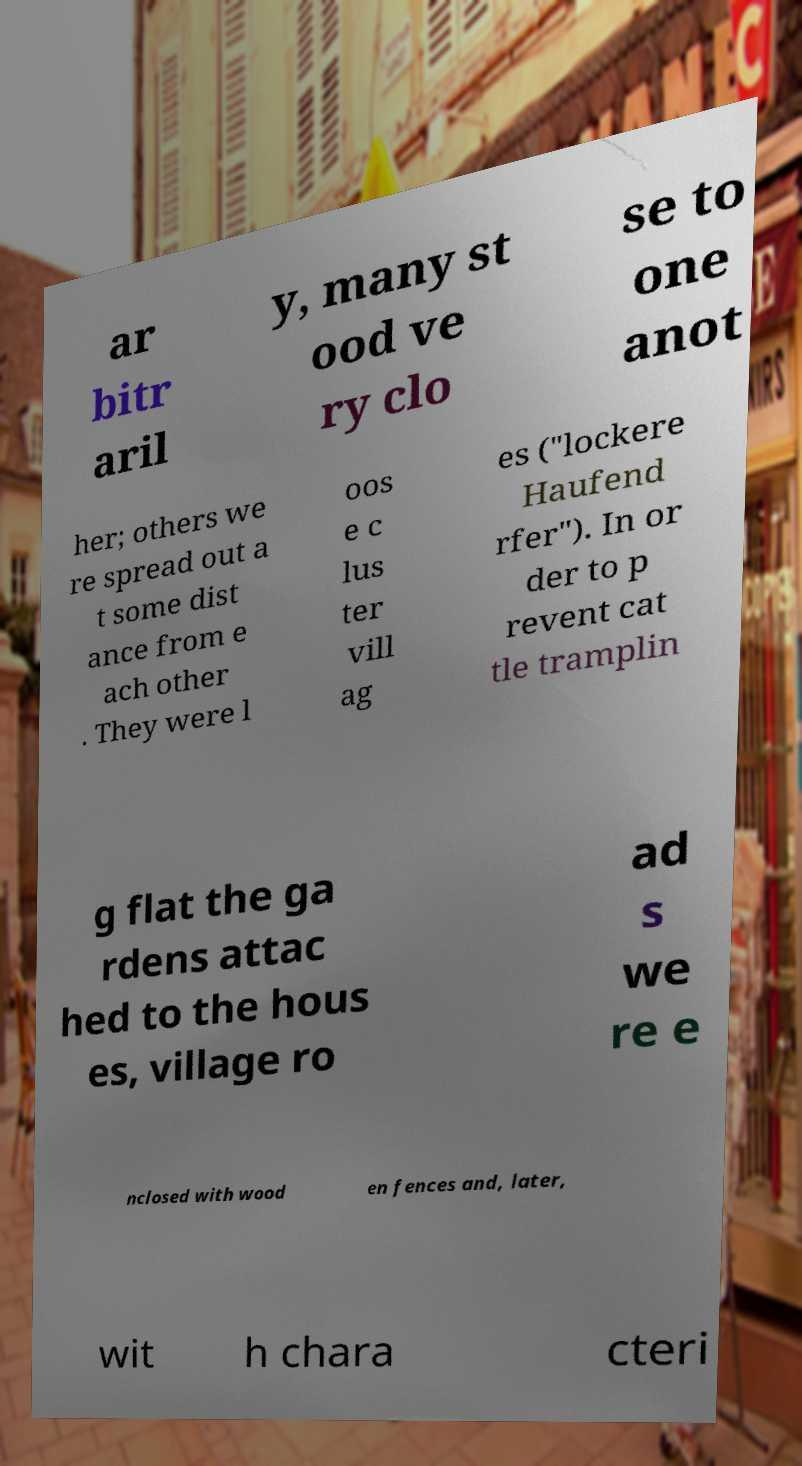For documentation purposes, I need the text within this image transcribed. Could you provide that? ar bitr aril y, many st ood ve ry clo se to one anot her; others we re spread out a t some dist ance from e ach other . They were l oos e c lus ter vill ag es ("lockere Haufend rfer"). In or der to p revent cat tle tramplin g flat the ga rdens attac hed to the hous es, village ro ad s we re e nclosed with wood en fences and, later, wit h chara cteri 